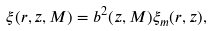<formula> <loc_0><loc_0><loc_500><loc_500>\xi ( r , z , M ) = b ^ { 2 } ( z , M ) \xi _ { m } ( r , z ) ,</formula> 